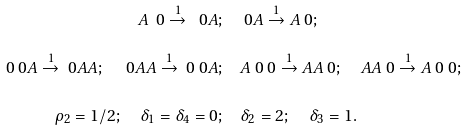Convert formula to latex. <formula><loc_0><loc_0><loc_500><loc_500>A \ 0 \overset { 1 } { \to } \ 0 A ; & \quad \ 0 A \overset { 1 } { \to } A \ 0 ; \\ \ 0 \ 0 A \overset { 1 } { \to } \ 0 A A ; \quad \ 0 A A \overset { 1 } { \to } \ 0 \ 0 A ; & \quad A \ 0 \ 0 \overset { 1 } { \to } A A \ 0 ; \quad A A \ 0 \overset { 1 } { \to } A \ 0 \ 0 ; \\ \rho _ { 2 } = 1 / 2 ; \quad \delta _ { 1 } = \delta _ { 4 } = 0 ; & \quad \delta _ { 2 } = 2 ; \quad \delta _ { 3 } = 1 .</formula> 